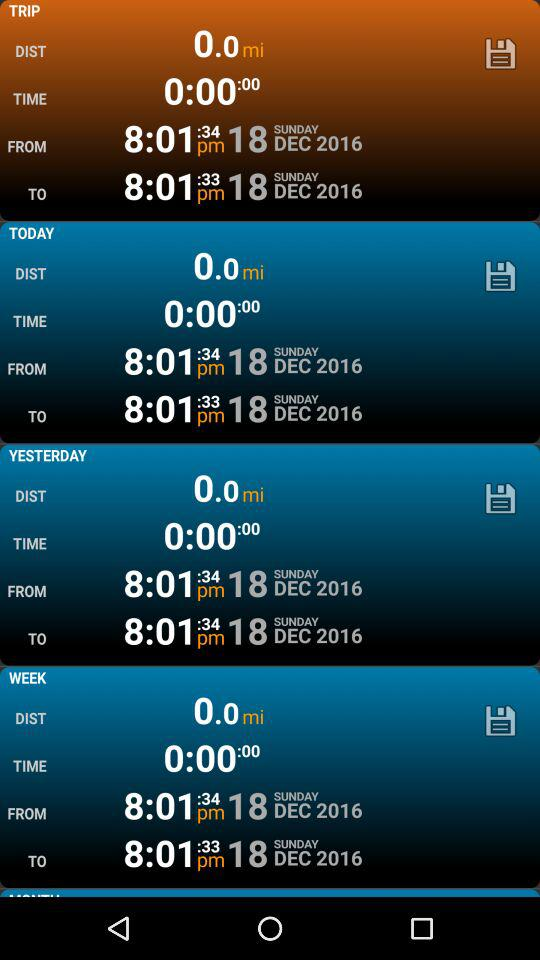How many more minutes are there from 8:01 to 8:34?
Answer the question using a single word or phrase. 33 